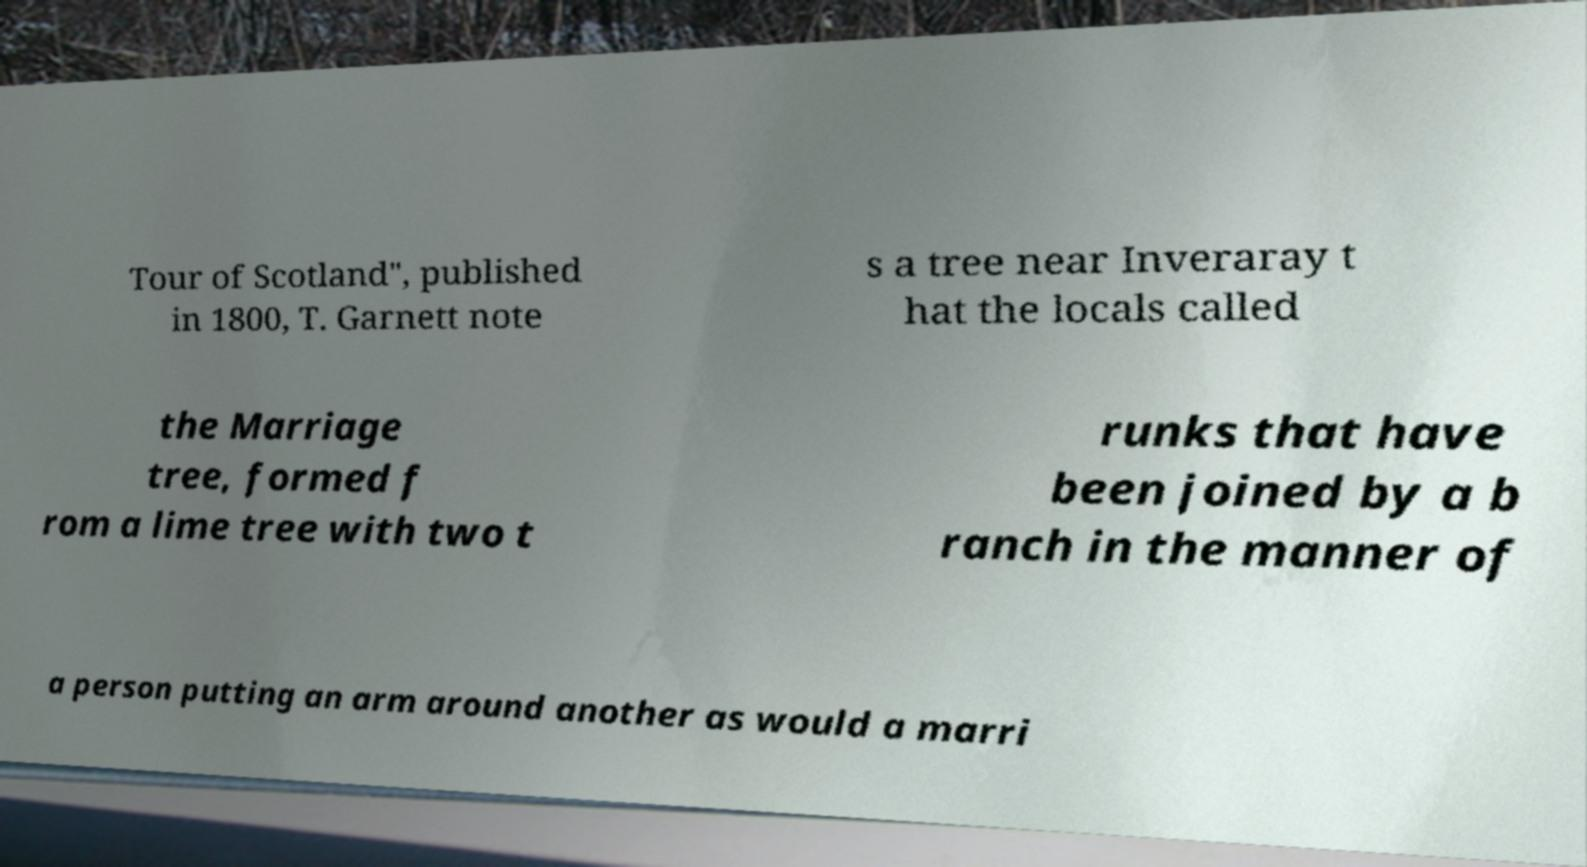Can you read and provide the text displayed in the image?This photo seems to have some interesting text. Can you extract and type it out for me? Tour of Scotland", published in 1800, T. Garnett note s a tree near Inveraray t hat the locals called the Marriage tree, formed f rom a lime tree with two t runks that have been joined by a b ranch in the manner of a person putting an arm around another as would a marri 